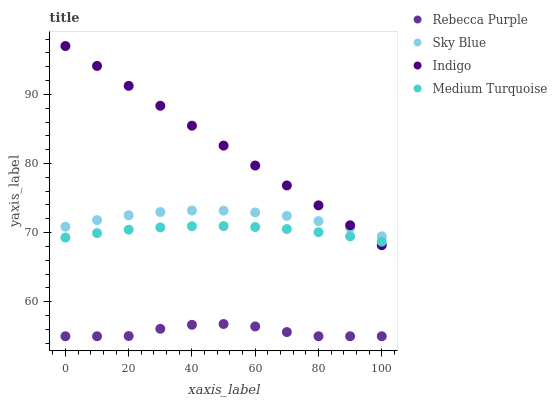Does Rebecca Purple have the minimum area under the curve?
Answer yes or no. Yes. Does Indigo have the maximum area under the curve?
Answer yes or no. Yes. Does Indigo have the minimum area under the curve?
Answer yes or no. No. Does Rebecca Purple have the maximum area under the curve?
Answer yes or no. No. Is Indigo the smoothest?
Answer yes or no. Yes. Is Rebecca Purple the roughest?
Answer yes or no. Yes. Is Rebecca Purple the smoothest?
Answer yes or no. No. Is Indigo the roughest?
Answer yes or no. No. Does Rebecca Purple have the lowest value?
Answer yes or no. Yes. Does Indigo have the lowest value?
Answer yes or no. No. Does Indigo have the highest value?
Answer yes or no. Yes. Does Rebecca Purple have the highest value?
Answer yes or no. No. Is Rebecca Purple less than Sky Blue?
Answer yes or no. Yes. Is Sky Blue greater than Rebecca Purple?
Answer yes or no. Yes. Does Indigo intersect Medium Turquoise?
Answer yes or no. Yes. Is Indigo less than Medium Turquoise?
Answer yes or no. No. Is Indigo greater than Medium Turquoise?
Answer yes or no. No. Does Rebecca Purple intersect Sky Blue?
Answer yes or no. No. 